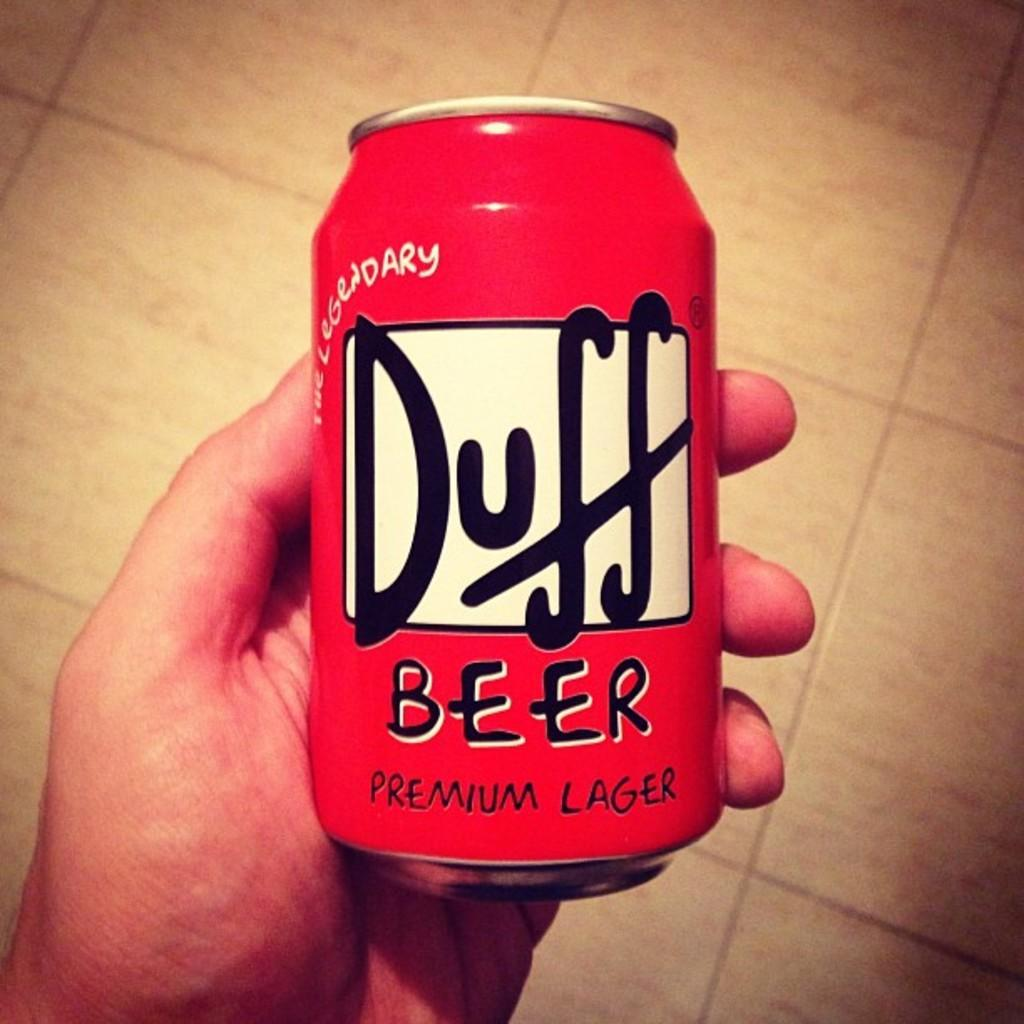<image>
Render a clear and concise summary of the photo. A hand is holding a red can of Duff beer. 